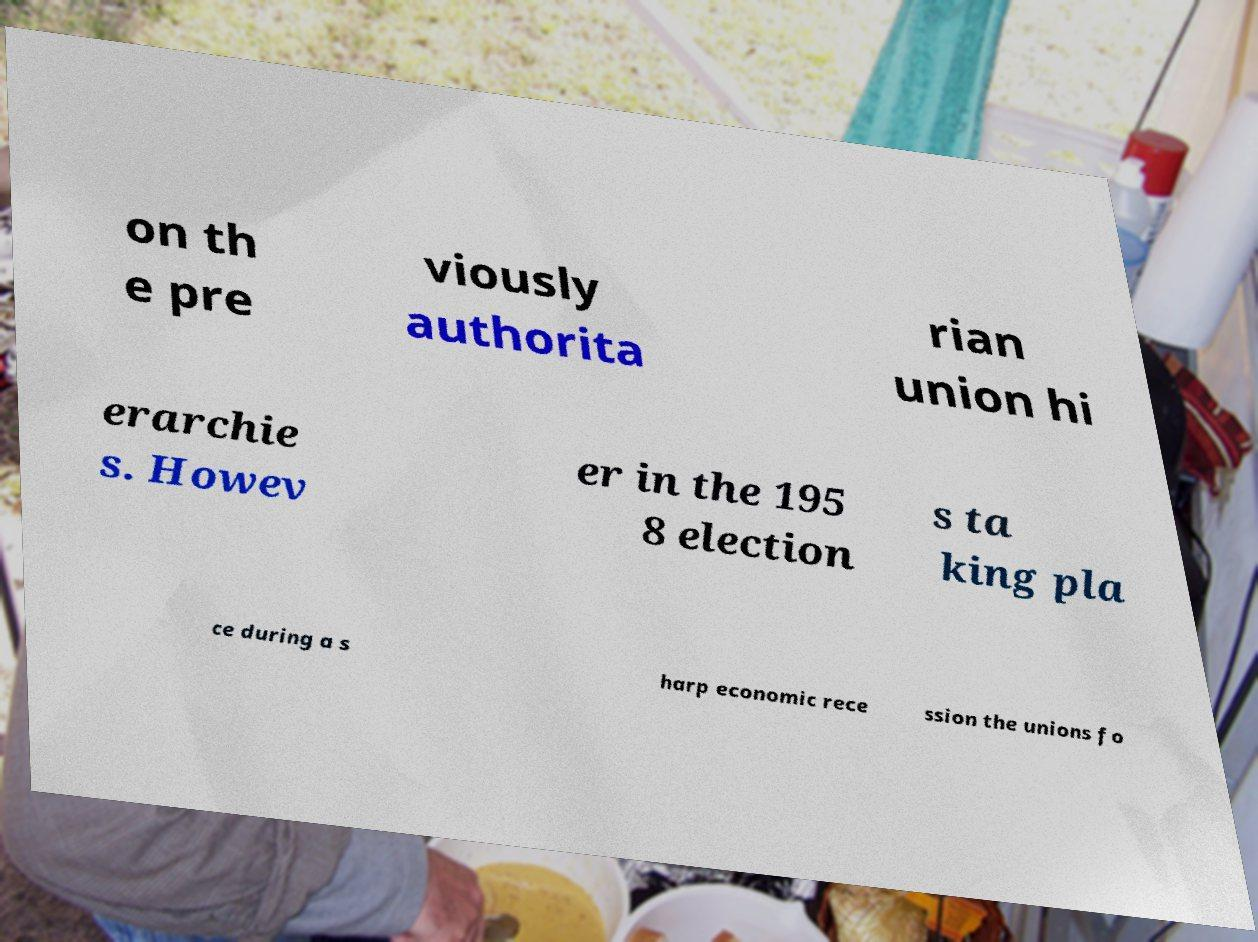I need the written content from this picture converted into text. Can you do that? on th e pre viously authorita rian union hi erarchie s. Howev er in the 195 8 election s ta king pla ce during a s harp economic rece ssion the unions fo 